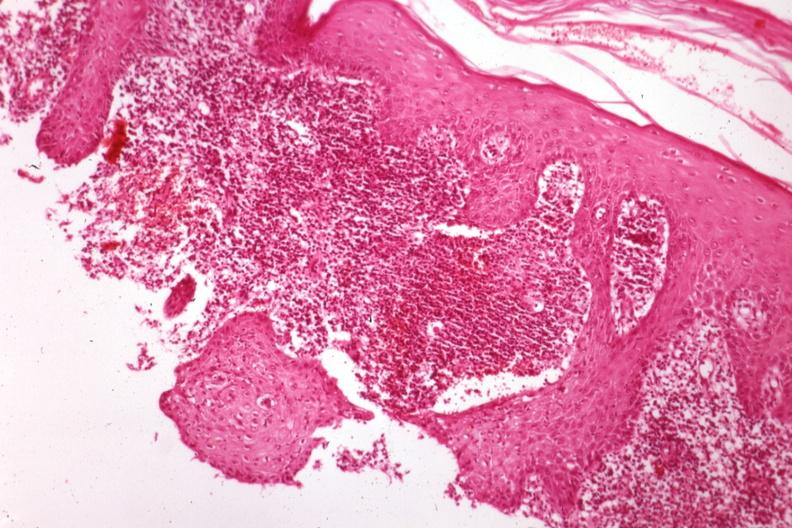s sporotrichosis present?
Answer the question using a single word or phrase. Yes 